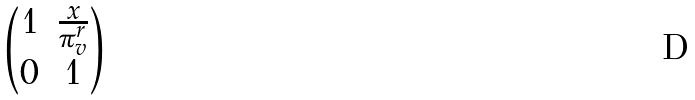Convert formula to latex. <formula><loc_0><loc_0><loc_500><loc_500>\begin{pmatrix} 1 & \frac { x } { \pi ^ { r } _ { v } } \\ 0 & 1 \end{pmatrix}</formula> 